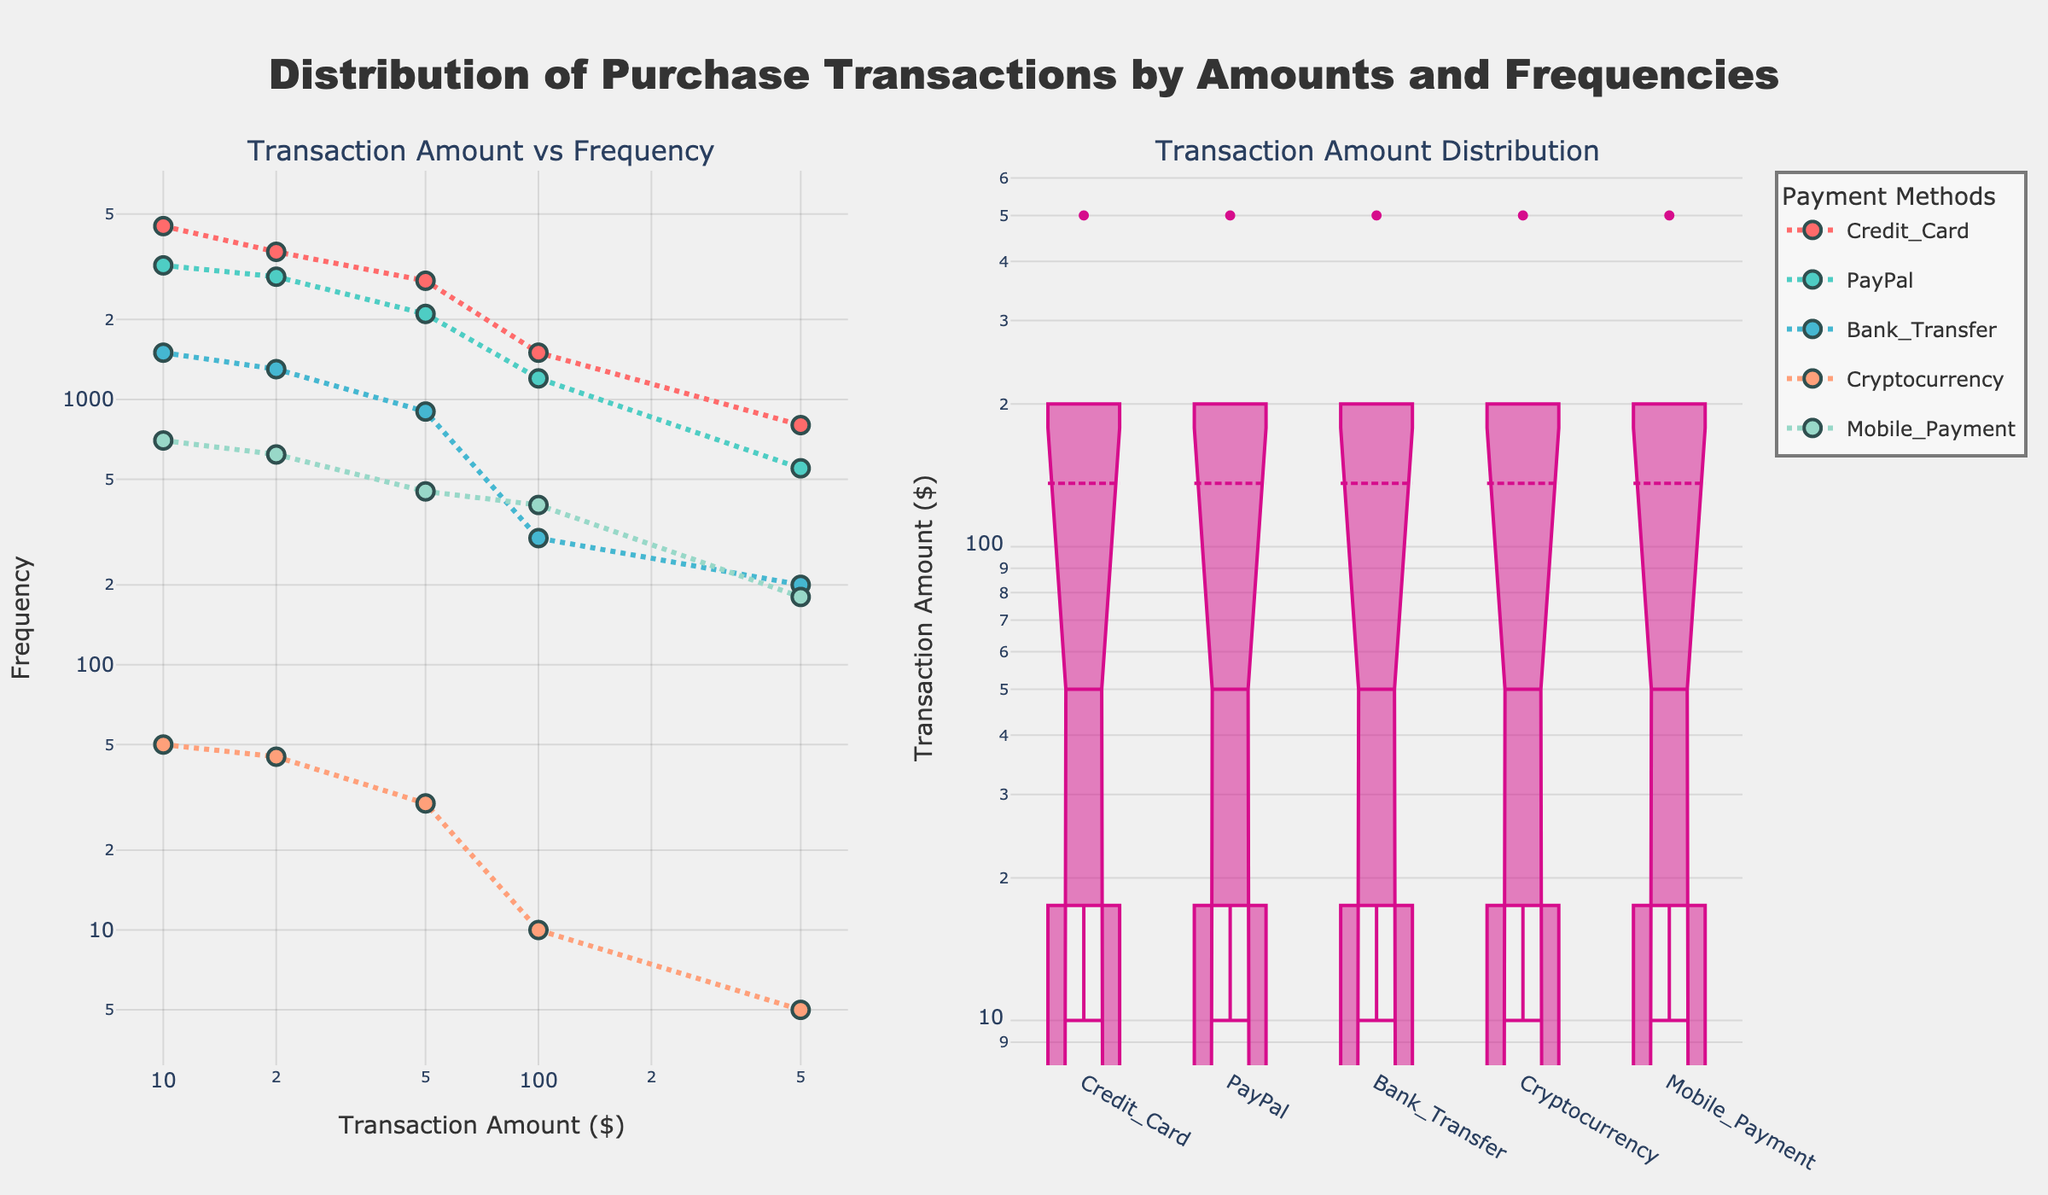What's the title of the figure? The title of the figure is located at the top center of the plot and clearly states the purpose of the visualization.
Answer: Distribution of Purchase Transactions by Amounts and Frequencies What's the x-axis label for the scatter plot on the left? The label for the x-axis of the scatter plot on the left can be found at the bottom of the grid marking the axis.
Answer: Transaction Amount ($) Which payment method has the highest frequency of $10 transactions? Looking at the data points for $10 transaction amounts in the scatter plot, we can see that Credit_Card has the highest frequency point.
Answer: Credit_Card How many different payment methods are compared in this figure? By counting the number of unique legend labels, we can determine that there are five different payment methods illustrated.
Answer: 5 What is the range of transaction amounts shown in the scatter plot? The range of transaction amounts on the x-axis of the scatter plot can be determined by observing the minimum and maximum values.
Answer: $10 to $500 Which payment method shows the least frequent usage for $500 transactions? By comparing the frequencies of the $500 transactions across different payment methods in the scatter plot, it is obvious that Cryptocurrency has the least frequent usage.
Answer: Cryptocurrency Are box plots or scatter plots used on the right subplot to illustrate transaction amounts? Observing the right subplot, we recognize that box plots, which are often used to show distributions, are employed to represent transaction amounts.
Answer: Box plots What does the box plot on the right reveal about the median transaction amount for PayPal? In the right subplot, examining the median line within the PayPal box plot reveals that the median transaction amount is $20.
Answer: $20 Which payment method exhibits the widest range of transaction amounts? By checking the length of the whiskers in the box plot on the right subplot, it becomes clear that Credit_Card displays the widest range.
Answer: Credit_Card For transactions of $100, which payment method has the highest frequency? Looking at the data points for $100 transaction amounts in the scatter plot, we can identify that Credit_Card has the highest frequency.
Answer: Credit_Card 